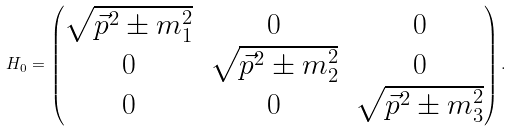Convert formula to latex. <formula><loc_0><loc_0><loc_500><loc_500>H _ { 0 } = \begin{pmatrix} \sqrt { \vec { p } ^ { 2 } \pm m _ { 1 } ^ { 2 } } & 0 & 0 \\ 0 & \sqrt { \vec { p } ^ { 2 } \pm m _ { 2 } ^ { 2 } } & 0 \\ 0 & 0 & \sqrt { \vec { p } ^ { 2 } \pm m _ { 3 } ^ { 2 } } \end{pmatrix} .</formula> 